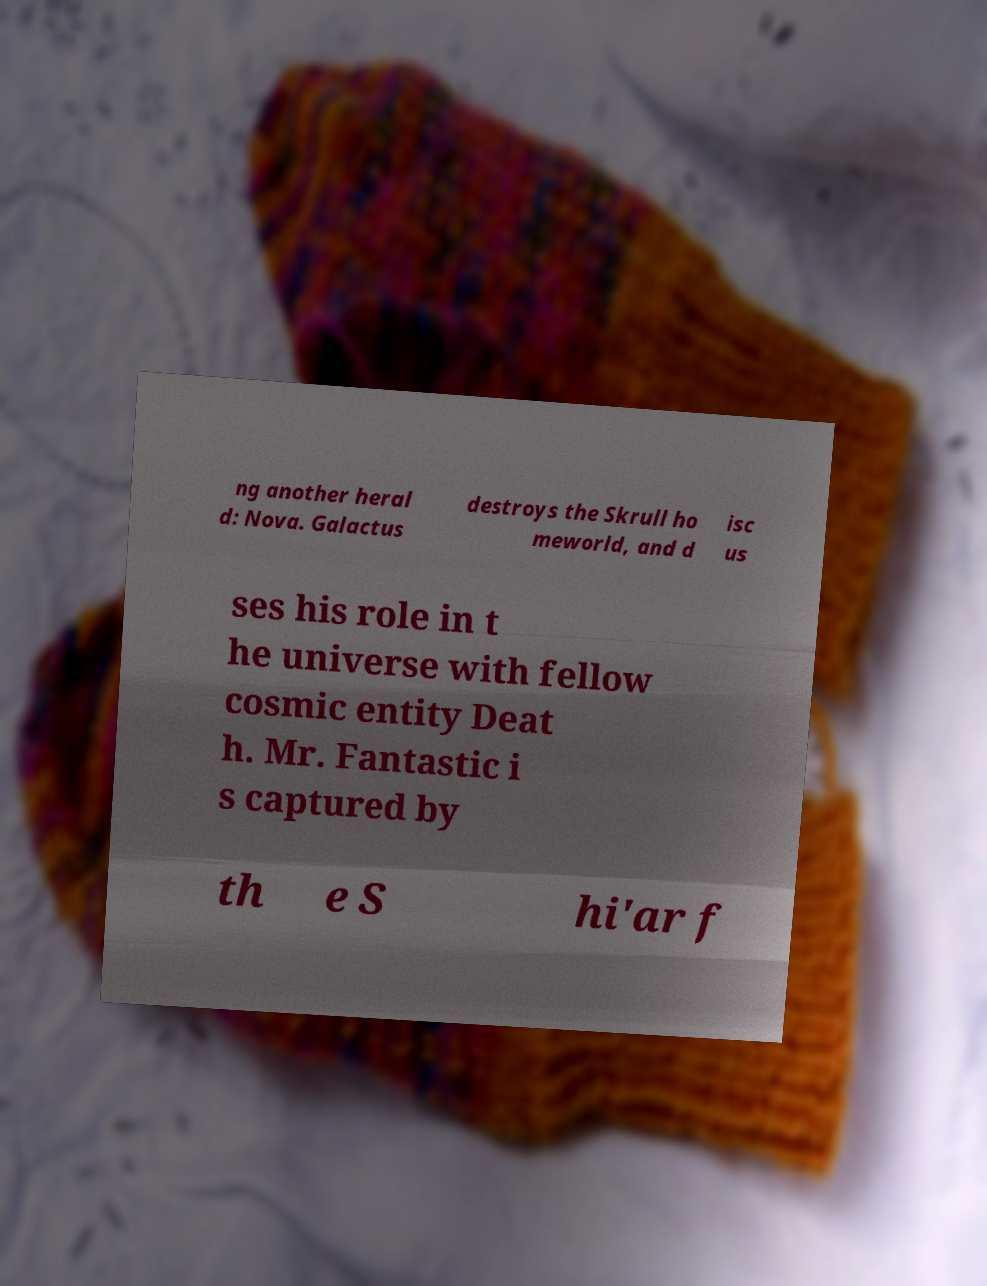Please read and relay the text visible in this image. What does it say? ng another heral d: Nova. Galactus destroys the Skrull ho meworld, and d isc us ses his role in t he universe with fellow cosmic entity Deat h. Mr. Fantastic i s captured by th e S hi'ar f 